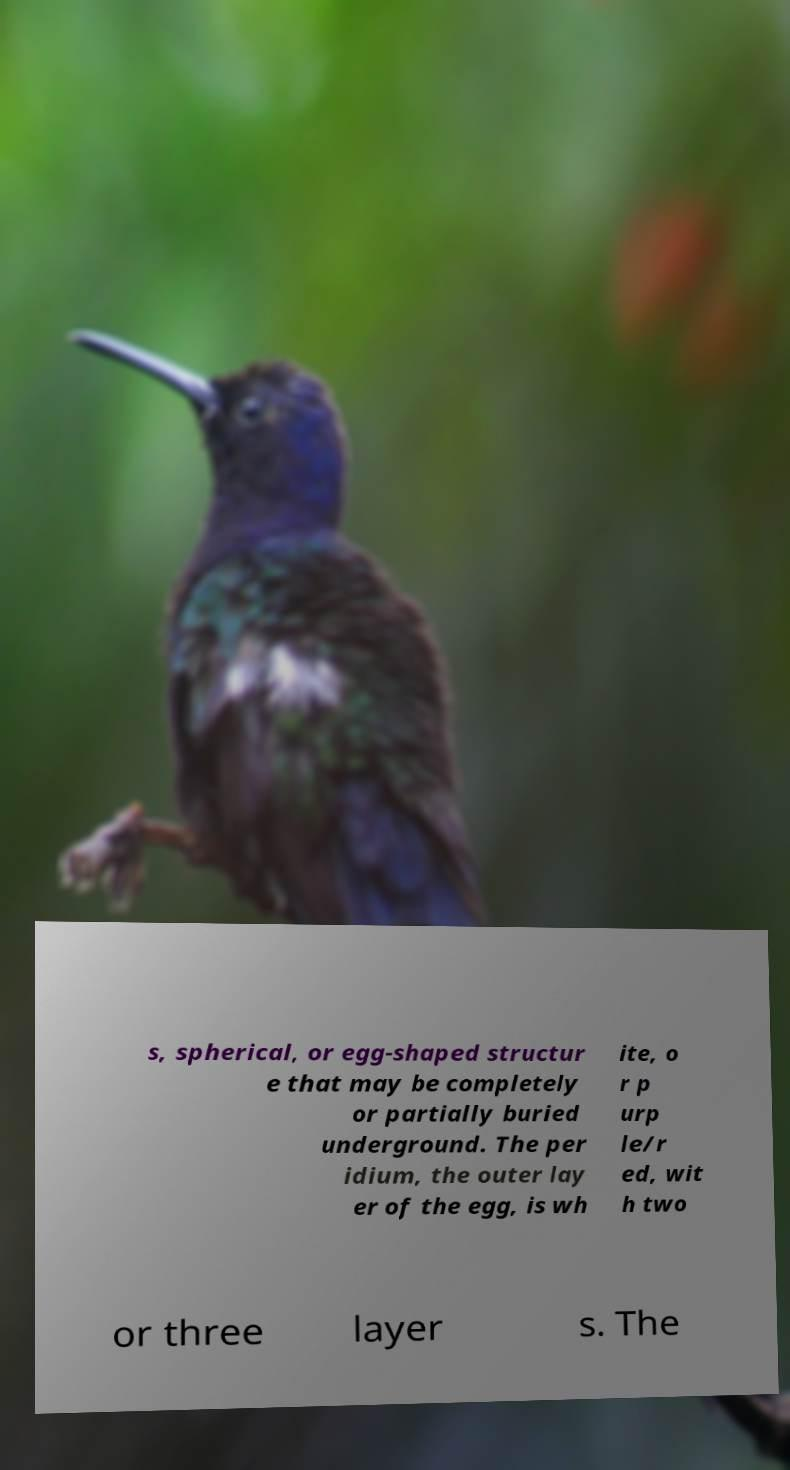I need the written content from this picture converted into text. Can you do that? s, spherical, or egg-shaped structur e that may be completely or partially buried underground. The per idium, the outer lay er of the egg, is wh ite, o r p urp le/r ed, wit h two or three layer s. The 